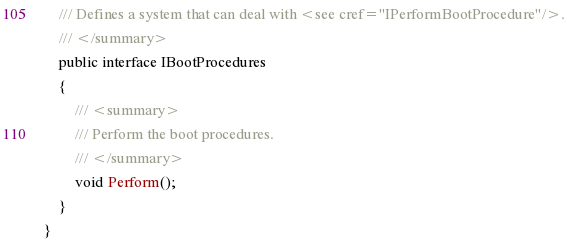<code> <loc_0><loc_0><loc_500><loc_500><_C#_>    /// Defines a system that can deal with <see cref="IPerformBootProcedure"/>.
    /// </summary>
    public interface IBootProcedures
    {
        /// <summary>
        /// Perform the boot procedures.
        /// </summary>
        void Perform();
    }
}
</code> 